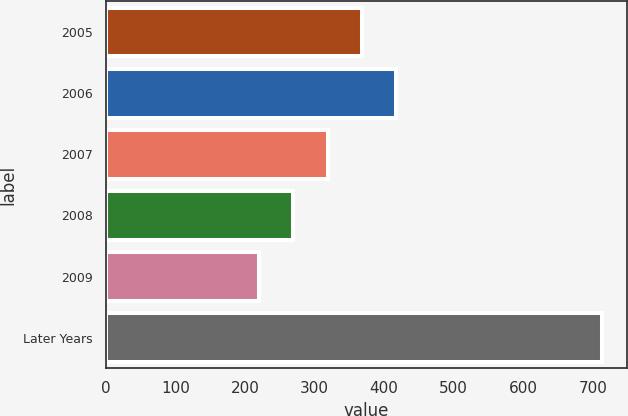<chart> <loc_0><loc_0><loc_500><loc_500><bar_chart><fcel>2005<fcel>2006<fcel>2007<fcel>2008<fcel>2009<fcel>Later Years<nl><fcel>368.2<fcel>417.6<fcel>318.8<fcel>269.4<fcel>220<fcel>714<nl></chart> 